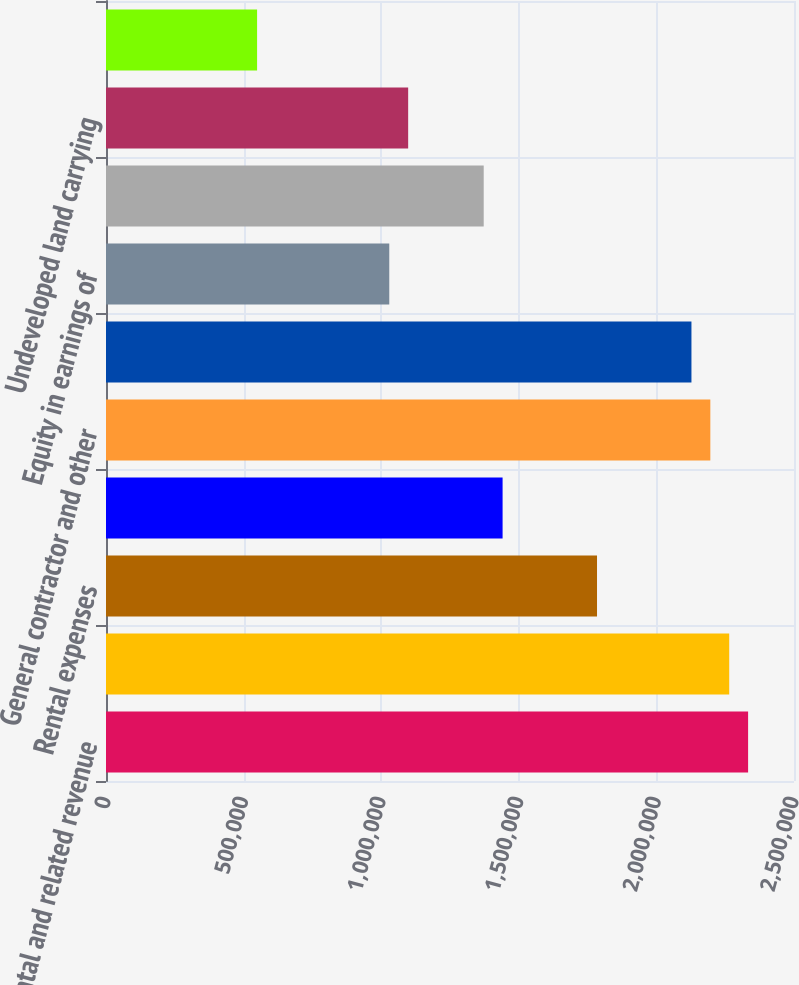<chart> <loc_0><loc_0><loc_500><loc_500><bar_chart><fcel>Rental and related revenue<fcel>General contractor and service<fcel>Rental expenses<fcel>Real estate taxes<fcel>General contractor and other<fcel>Depreciation and amortization<fcel>Equity in earnings of<fcel>Gain on sale of properties<fcel>Undeveloped land carrying<fcel>Other operating income<nl><fcel>2.33322e+06<fcel>2.2646e+06<fcel>1.78423e+06<fcel>1.44111e+06<fcel>2.19597e+06<fcel>2.12735e+06<fcel>1.02936e+06<fcel>1.37248e+06<fcel>1.09799e+06<fcel>548994<nl></chart> 